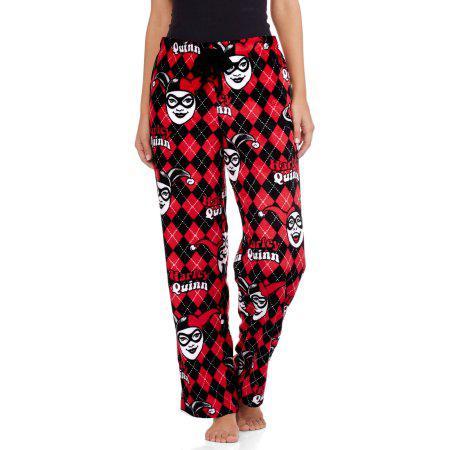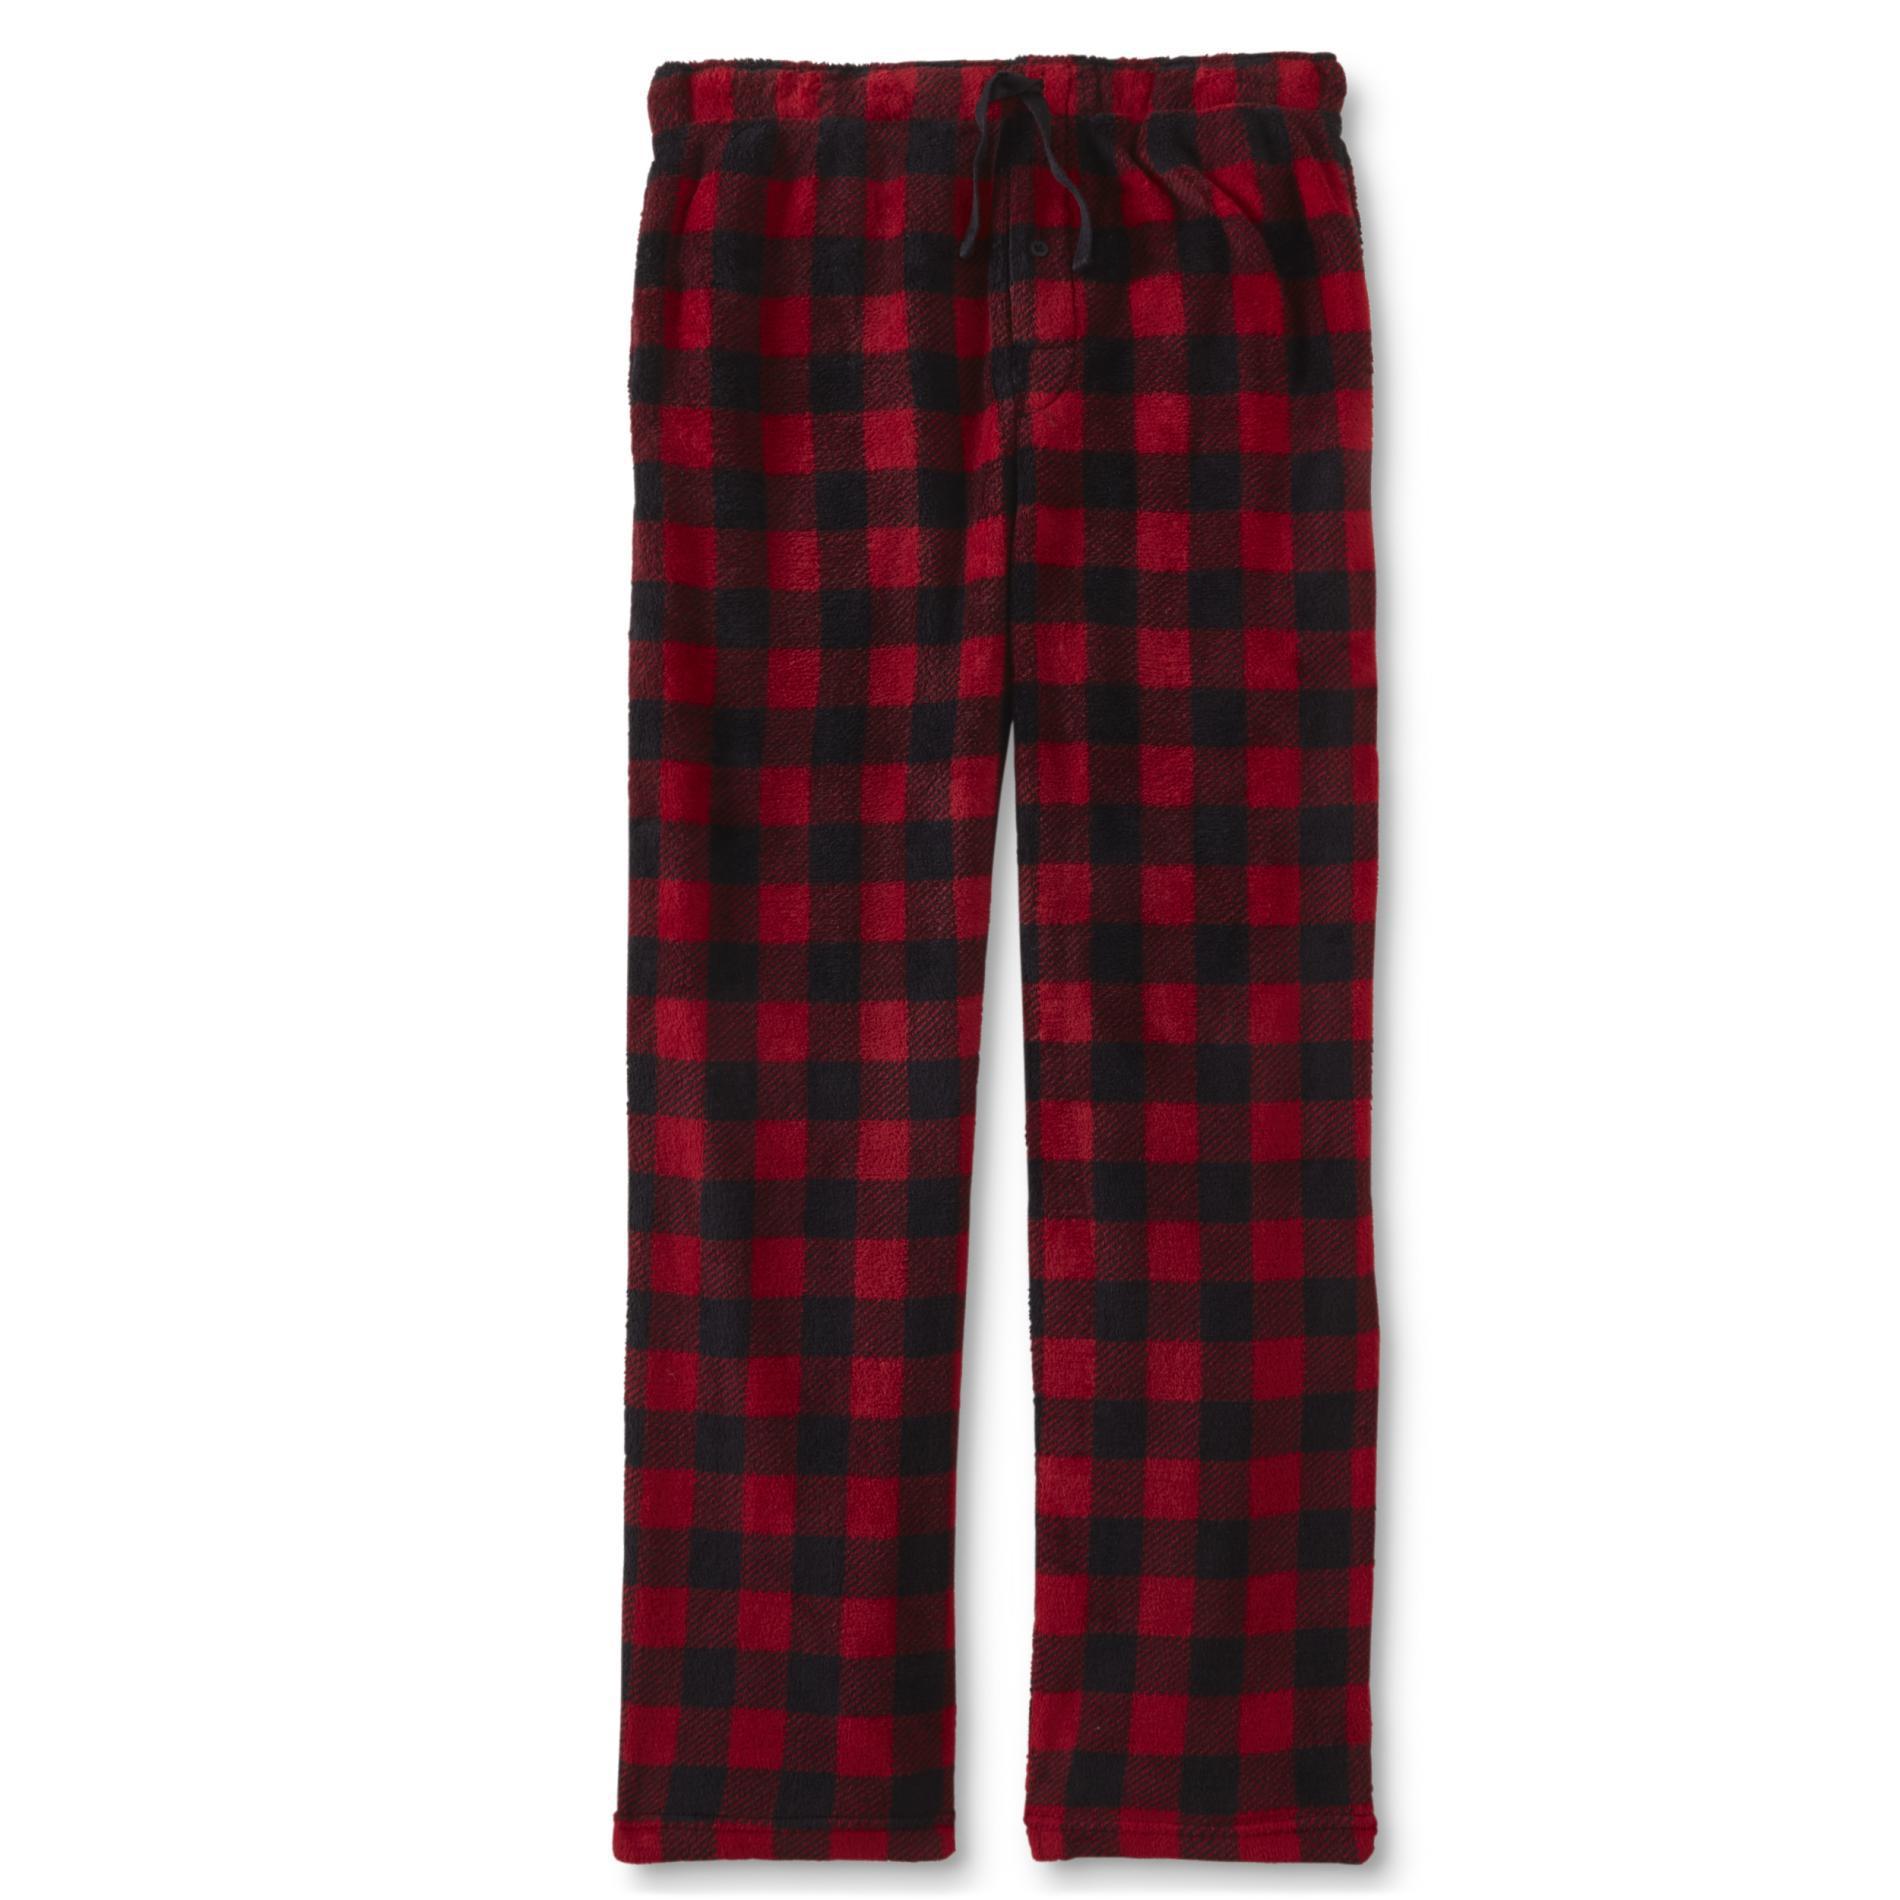The first image is the image on the left, the second image is the image on the right. Given the left and right images, does the statement "one pair of pants is worn by a human and the other is by itself." hold true? Answer yes or no. Yes. 